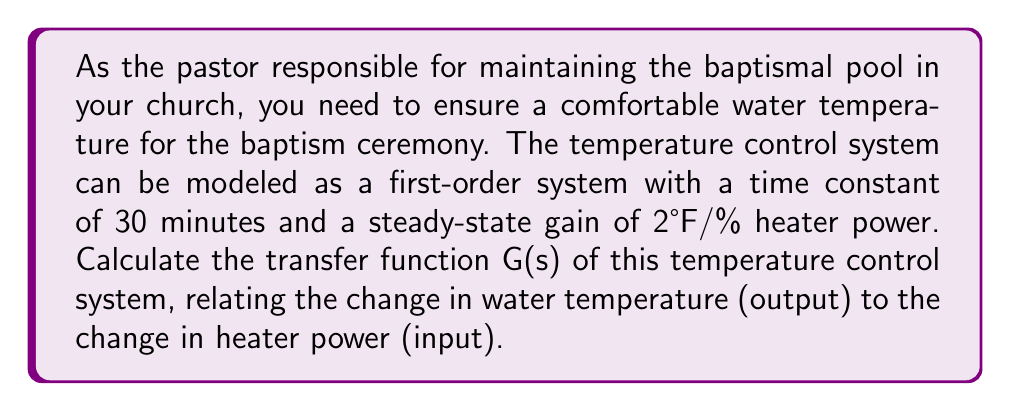Can you answer this question? To determine the transfer function of the temperature control system for the baptismal pool, we'll follow these steps:

1. Identify the system parameters:
   - Time constant (τ) = 30 minutes
   - Steady-state gain (K) = 2°F/% heater power

2. Recall the general form of a first-order transfer function:
   
   $$G(s) = \frac{K}{\tau s + 1}$$

   Where:
   - K is the steady-state gain
   - τ is the time constant
   - s is the Laplace variable

3. Substitute the given values into the transfer function:
   
   $$G(s) = \frac{2}{30s + 1}$$

4. To express the transfer function in standard form, we need to convert the time constant from minutes to seconds:
   
   30 minutes = 30 × 60 seconds = 1800 seconds

5. Rewrite the transfer function with the time constant in seconds:
   
   $$G(s) = \frac{2}{1800s + 1}$$

This transfer function relates the change in water temperature (in °F) to the change in heater power (in %). It represents how the baptismal pool's temperature will respond to changes in the heater's power input.
Answer: $$G(s) = \frac{2}{1800s + 1}$$ 